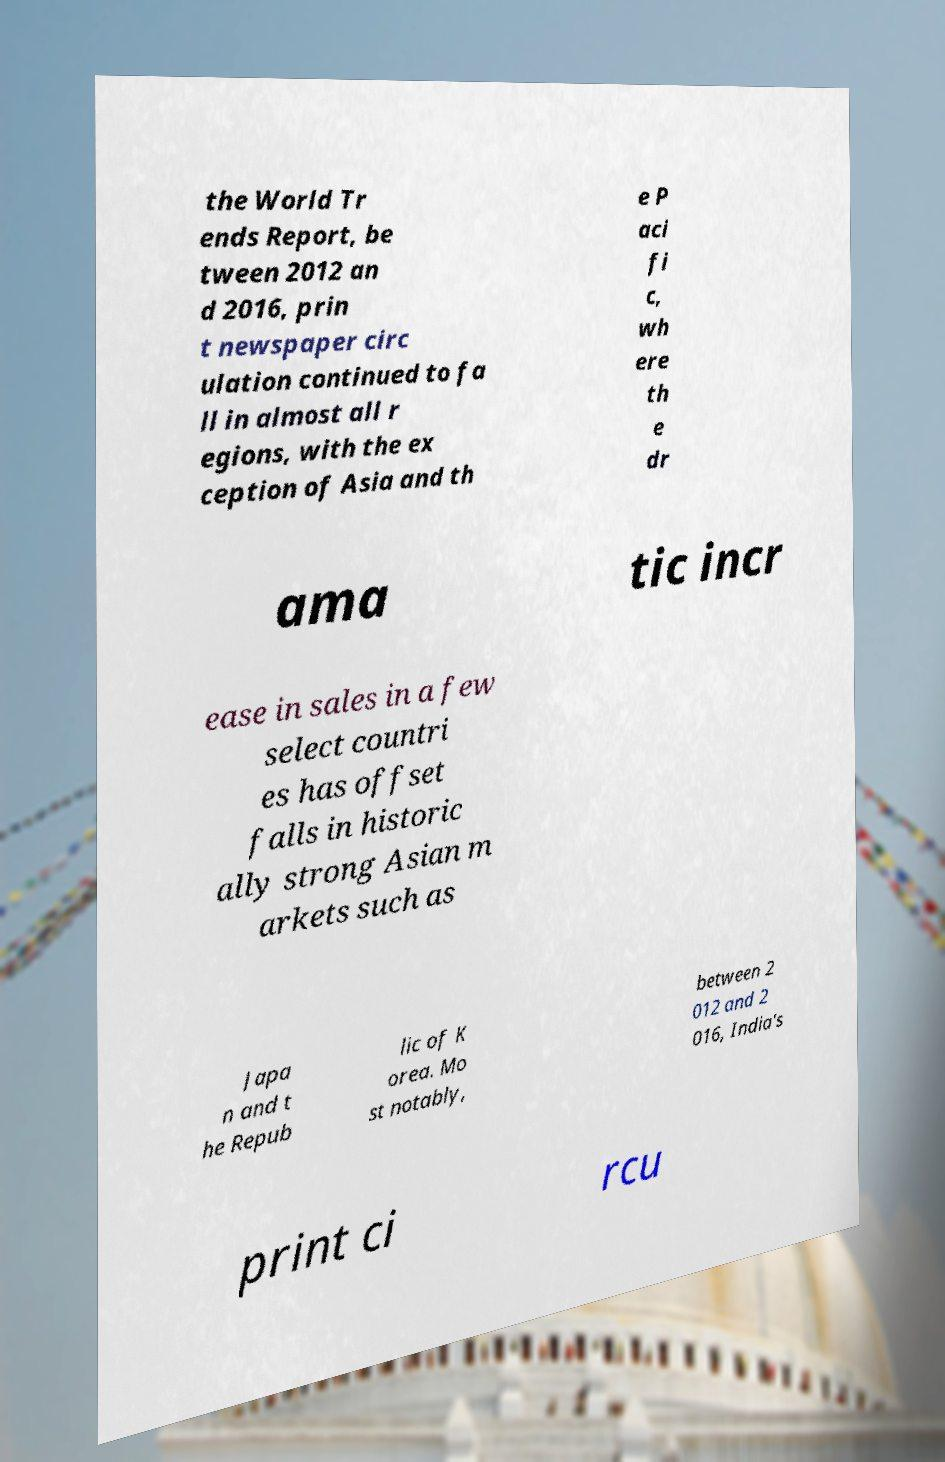Could you extract and type out the text from this image? the World Tr ends Report, be tween 2012 an d 2016, prin t newspaper circ ulation continued to fa ll in almost all r egions, with the ex ception of Asia and th e P aci fi c, wh ere th e dr ama tic incr ease in sales in a few select countri es has offset falls in historic ally strong Asian m arkets such as Japa n and t he Repub lic of K orea. Mo st notably, between 2 012 and 2 016, India's print ci rcu 